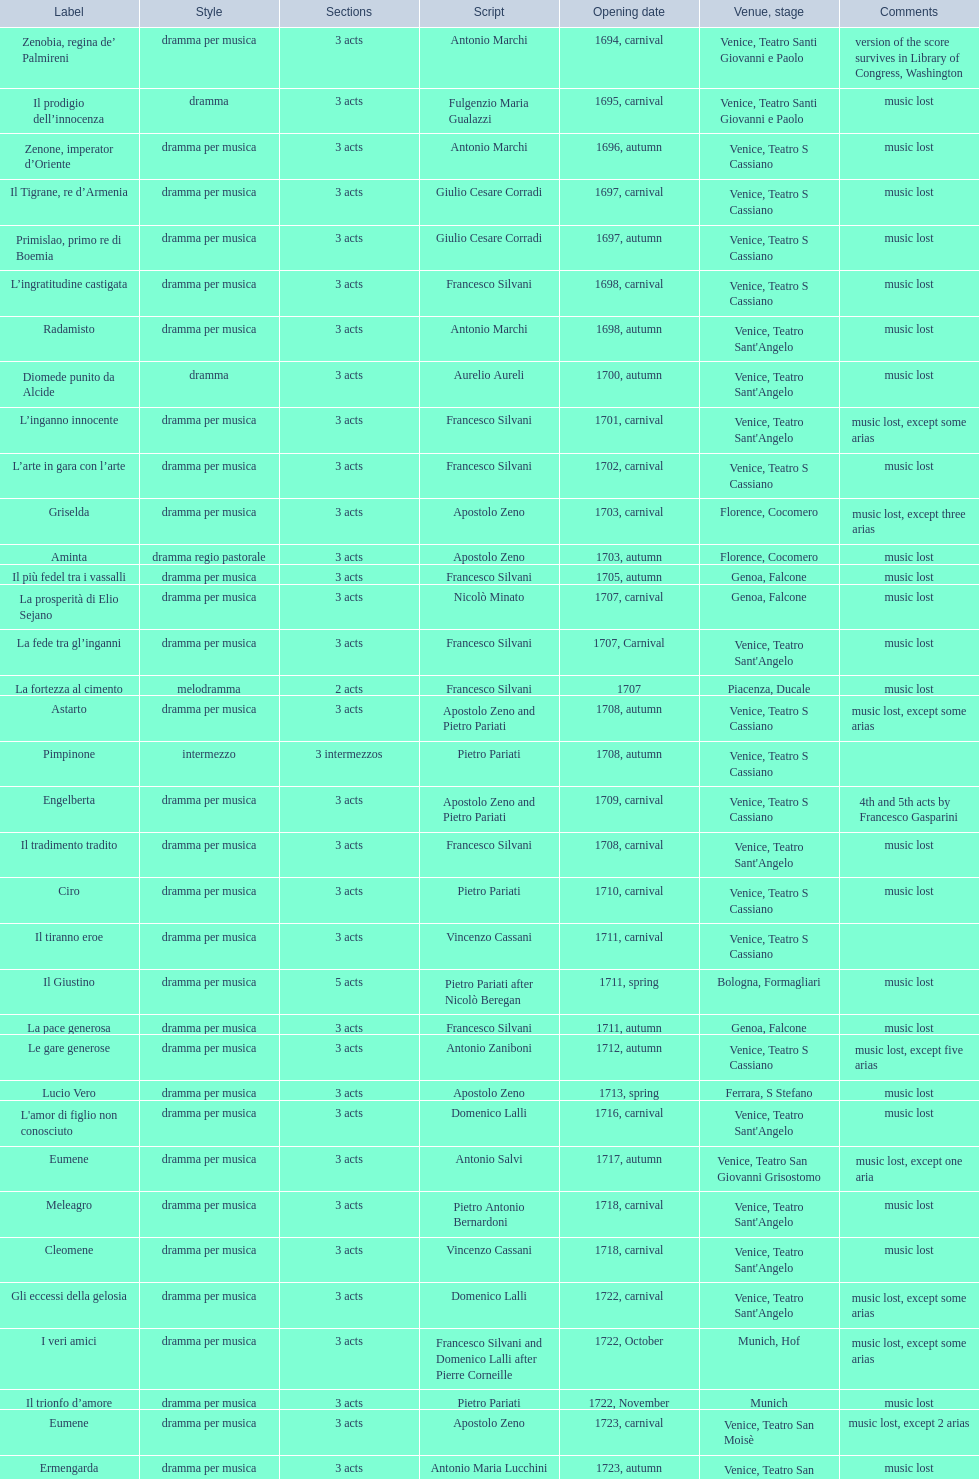How many operas on this list has at least 3 acts? 51. 